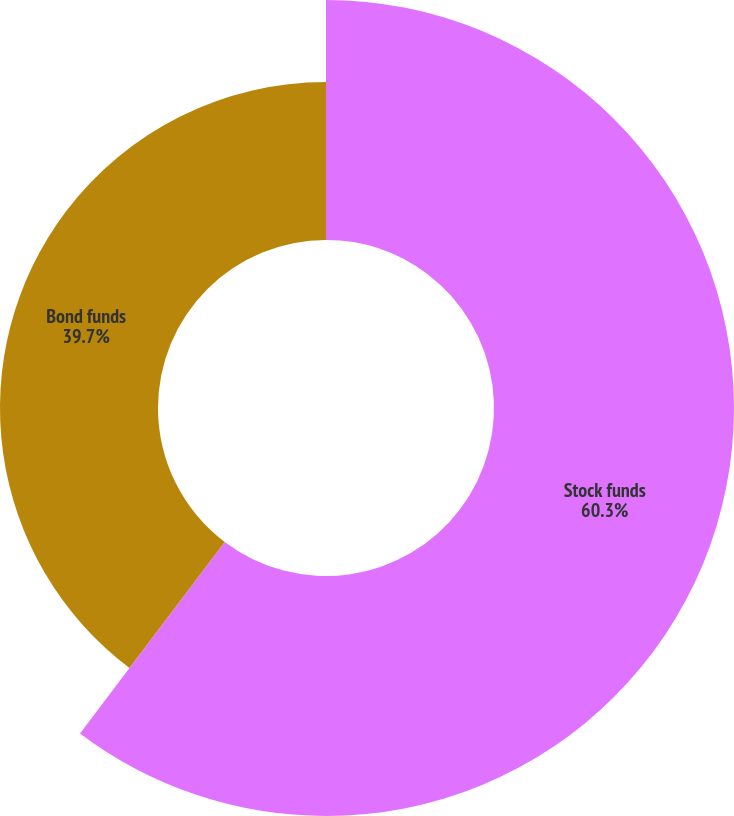Convert chart to OTSL. <chart><loc_0><loc_0><loc_500><loc_500><pie_chart><fcel>Stock funds<fcel>Bond funds<nl><fcel>60.3%<fcel>39.7%<nl></chart> 